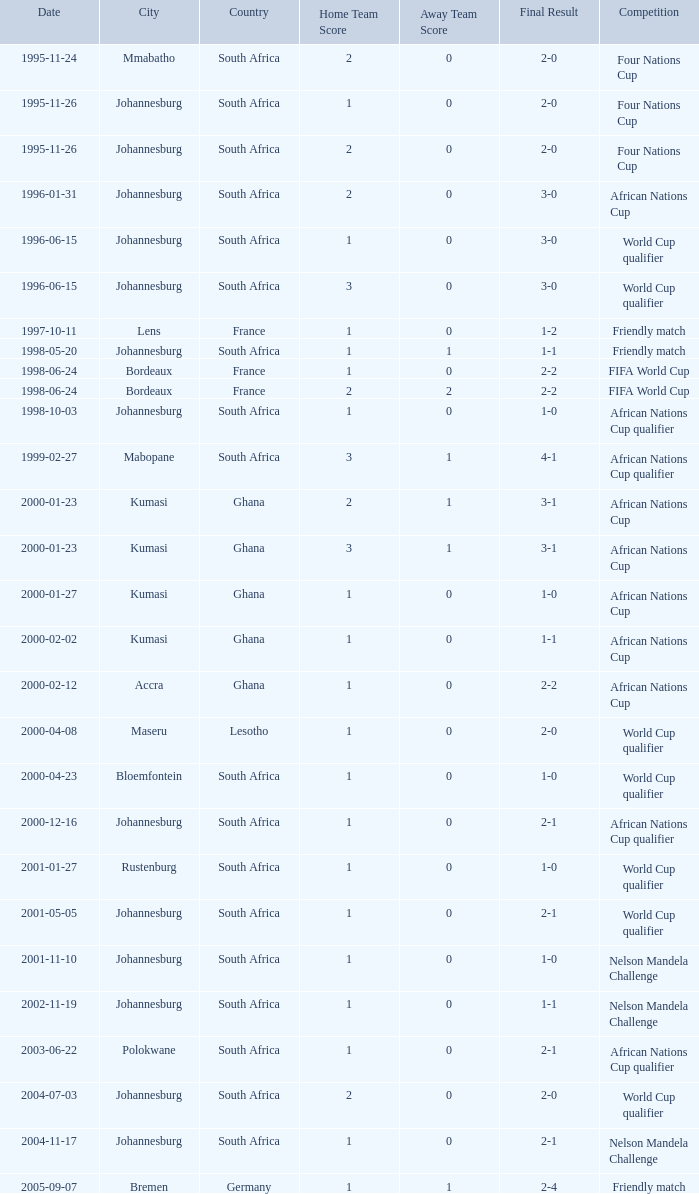What is the Date of the Fifa World Cup with a Score of 1-0? 1998-06-24. 